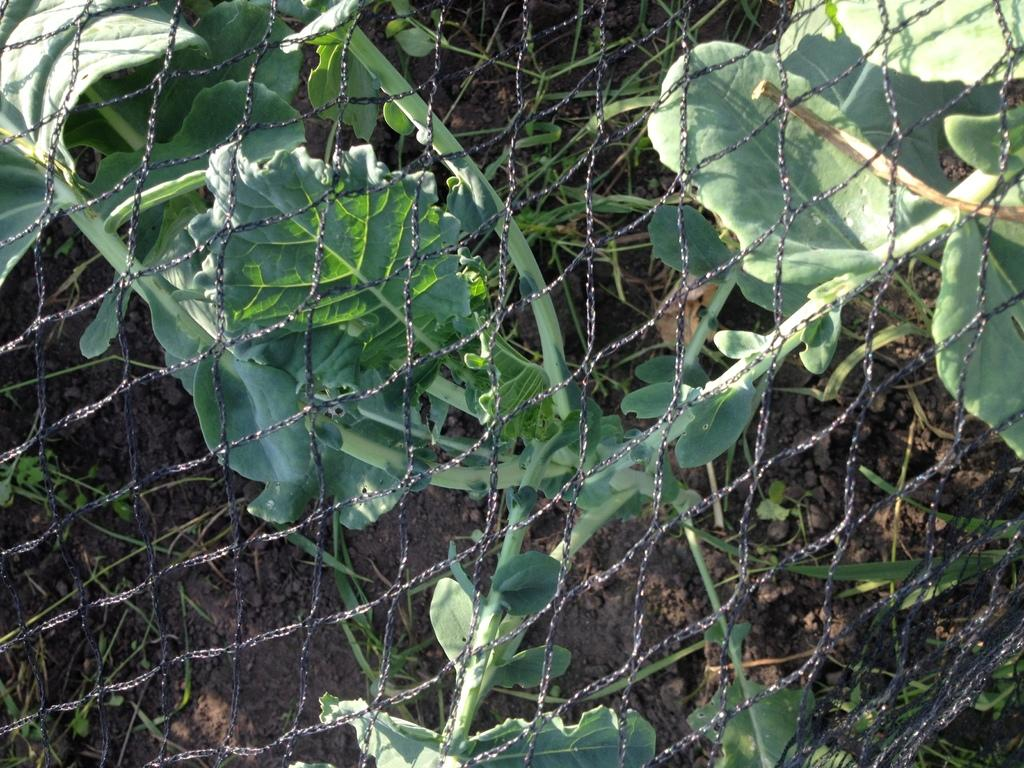What type of structure is present in the image? There is fencing in the image. How is the fencing positioned in relation to the other elements in the image? The fencing is in front of the other elements in the image. What can be seen through the fencing? There are plants visible through the fencing. What is the ground made of in the image? Soil is present in the image. What type of leather is being used to make the girl's dress in the image? There is no girl or dress present in the image; it features fencing and plants. 